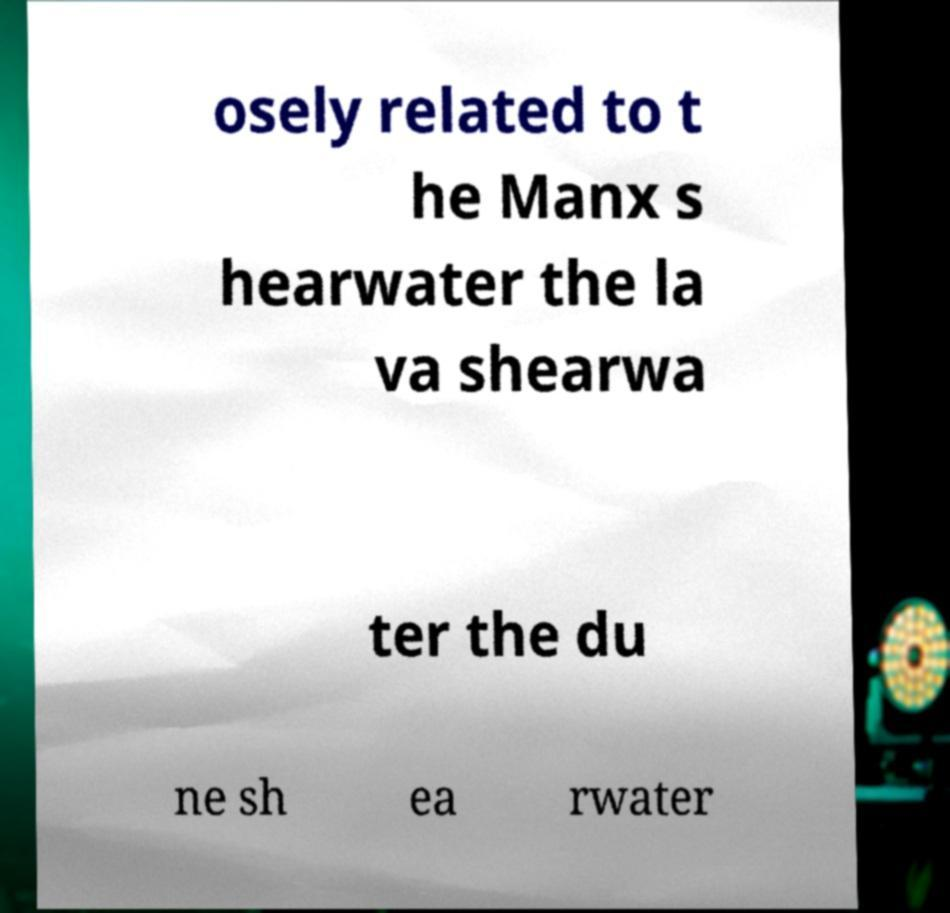Can you read and provide the text displayed in the image?This photo seems to have some interesting text. Can you extract and type it out for me? osely related to t he Manx s hearwater the la va shearwa ter the du ne sh ea rwater 